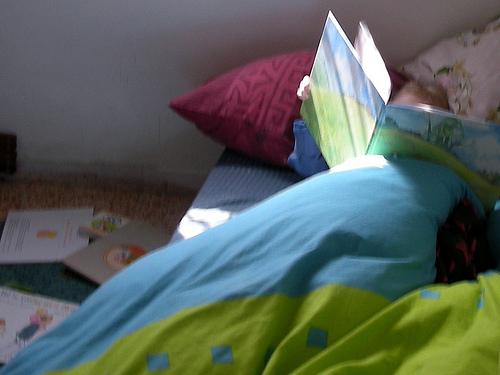What is the child doing?
Quick response, please. Reading. What color is the wall?
Give a very brief answer. White. Is this child in the kitchen?
Give a very brief answer. No. 